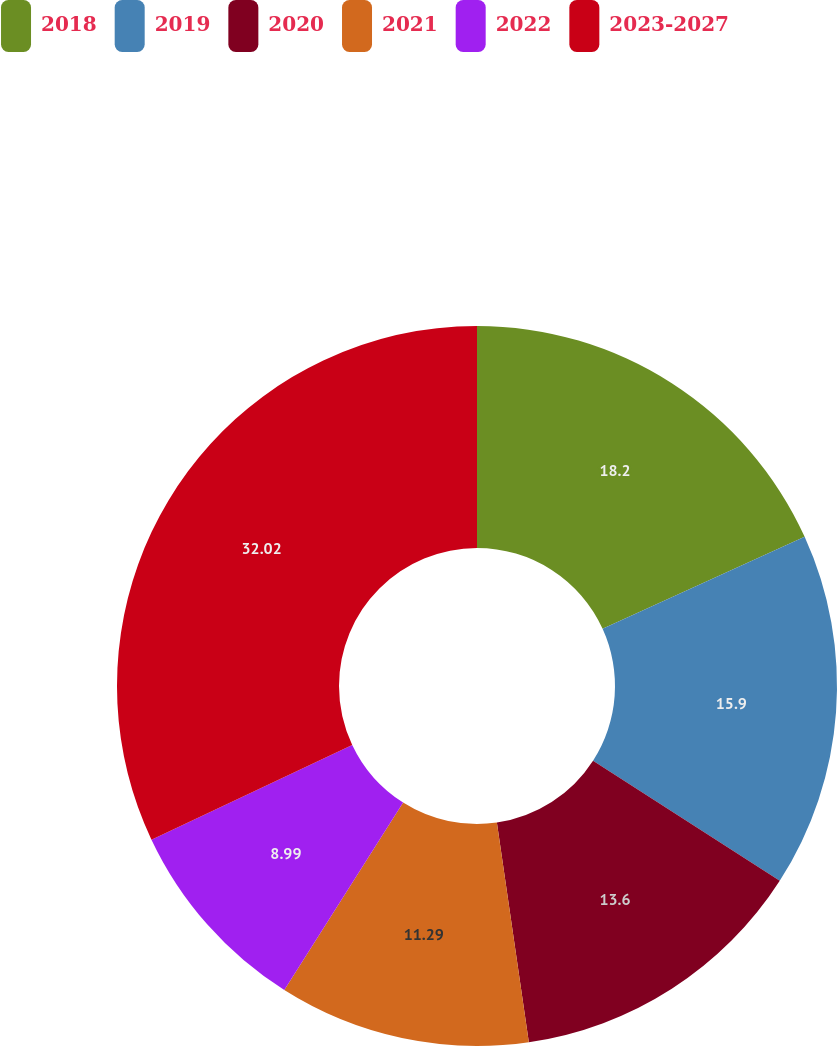Convert chart to OTSL. <chart><loc_0><loc_0><loc_500><loc_500><pie_chart><fcel>2018<fcel>2019<fcel>2020<fcel>2021<fcel>2022<fcel>2023-2027<nl><fcel>18.2%<fcel>15.9%<fcel>13.6%<fcel>11.29%<fcel>8.99%<fcel>32.02%<nl></chart> 